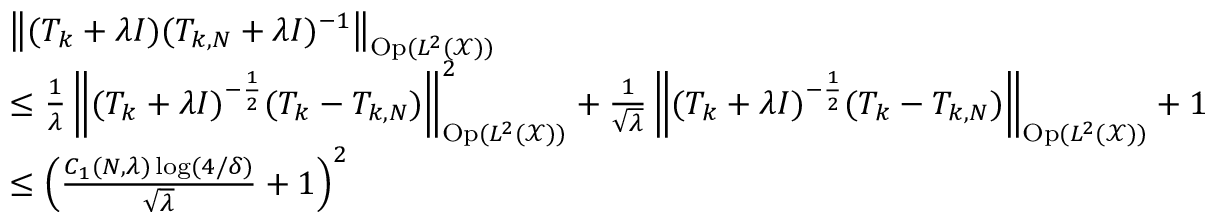<formula> <loc_0><loc_0><loc_500><loc_500>\begin{array} { r l } & { \left \| ( T _ { k } + \lambda I ) ( T _ { k , N } + \lambda I ) ^ { - 1 } \right \| _ { O p ( L ^ { 2 } ( \mathcal { X } ) ) } } \\ & { \leq \frac { 1 } { \lambda } \left \| ( T _ { k } + \lambda I ) ^ { - \frac { 1 } { 2 } } ( T _ { k } - T _ { k , N } ) \right \| _ { O p ( L ^ { 2 } ( \mathcal { X } ) ) } ^ { 2 } + \frac { 1 } { \sqrt { \lambda } } \left \| ( T _ { k } + \lambda I ) ^ { - \frac { 1 } { 2 } } ( T _ { k } - T _ { k , N } ) \right \| _ { O p ( L ^ { 2 } ( \mathcal { X } ) ) } + 1 } \\ & { \leq \left ( \frac { C _ { 1 } ( N , \lambda ) \log ( 4 / \delta ) } { \sqrt { \lambda } } + 1 \right ) ^ { 2 } } \end{array}</formula> 